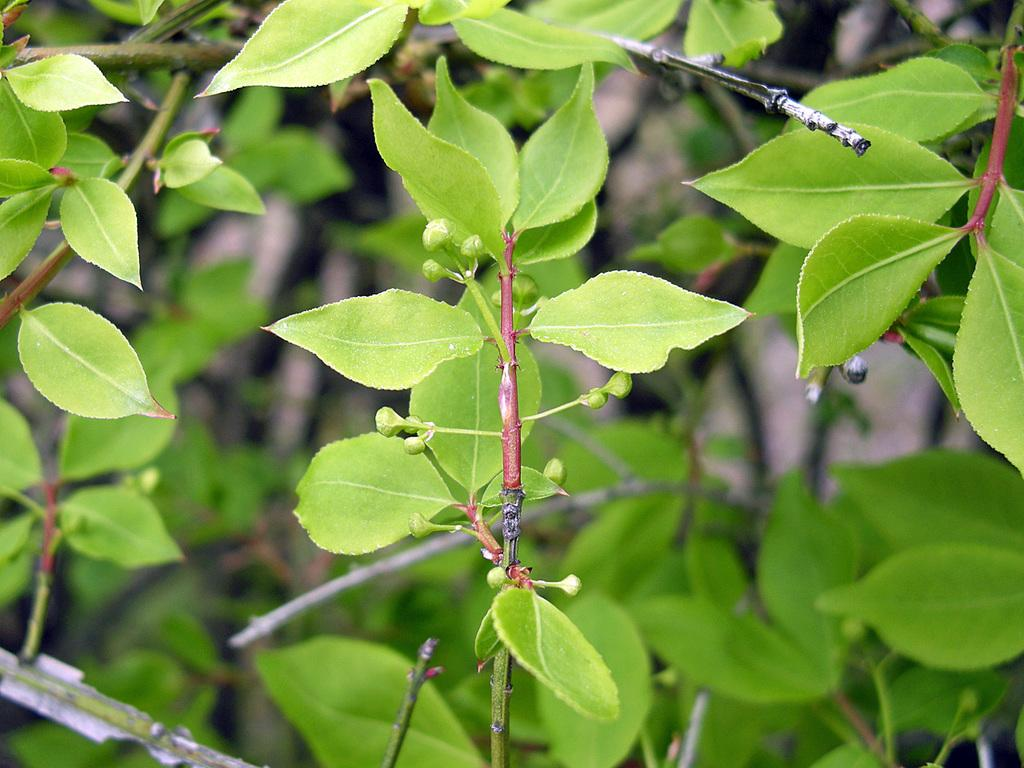What type of living organisms are present in the image? There are plants in the image. What color are the plants in the image? The plants are green in color. What stage of growth are the plants in? There are small buds on the plants, indicating they are in an early stage of growth. What type of property can be seen in the background of the image? There is no property visible in the image; it only features plants. What type of basketball court can be seen in the image? There is no basketball court present in the image. 